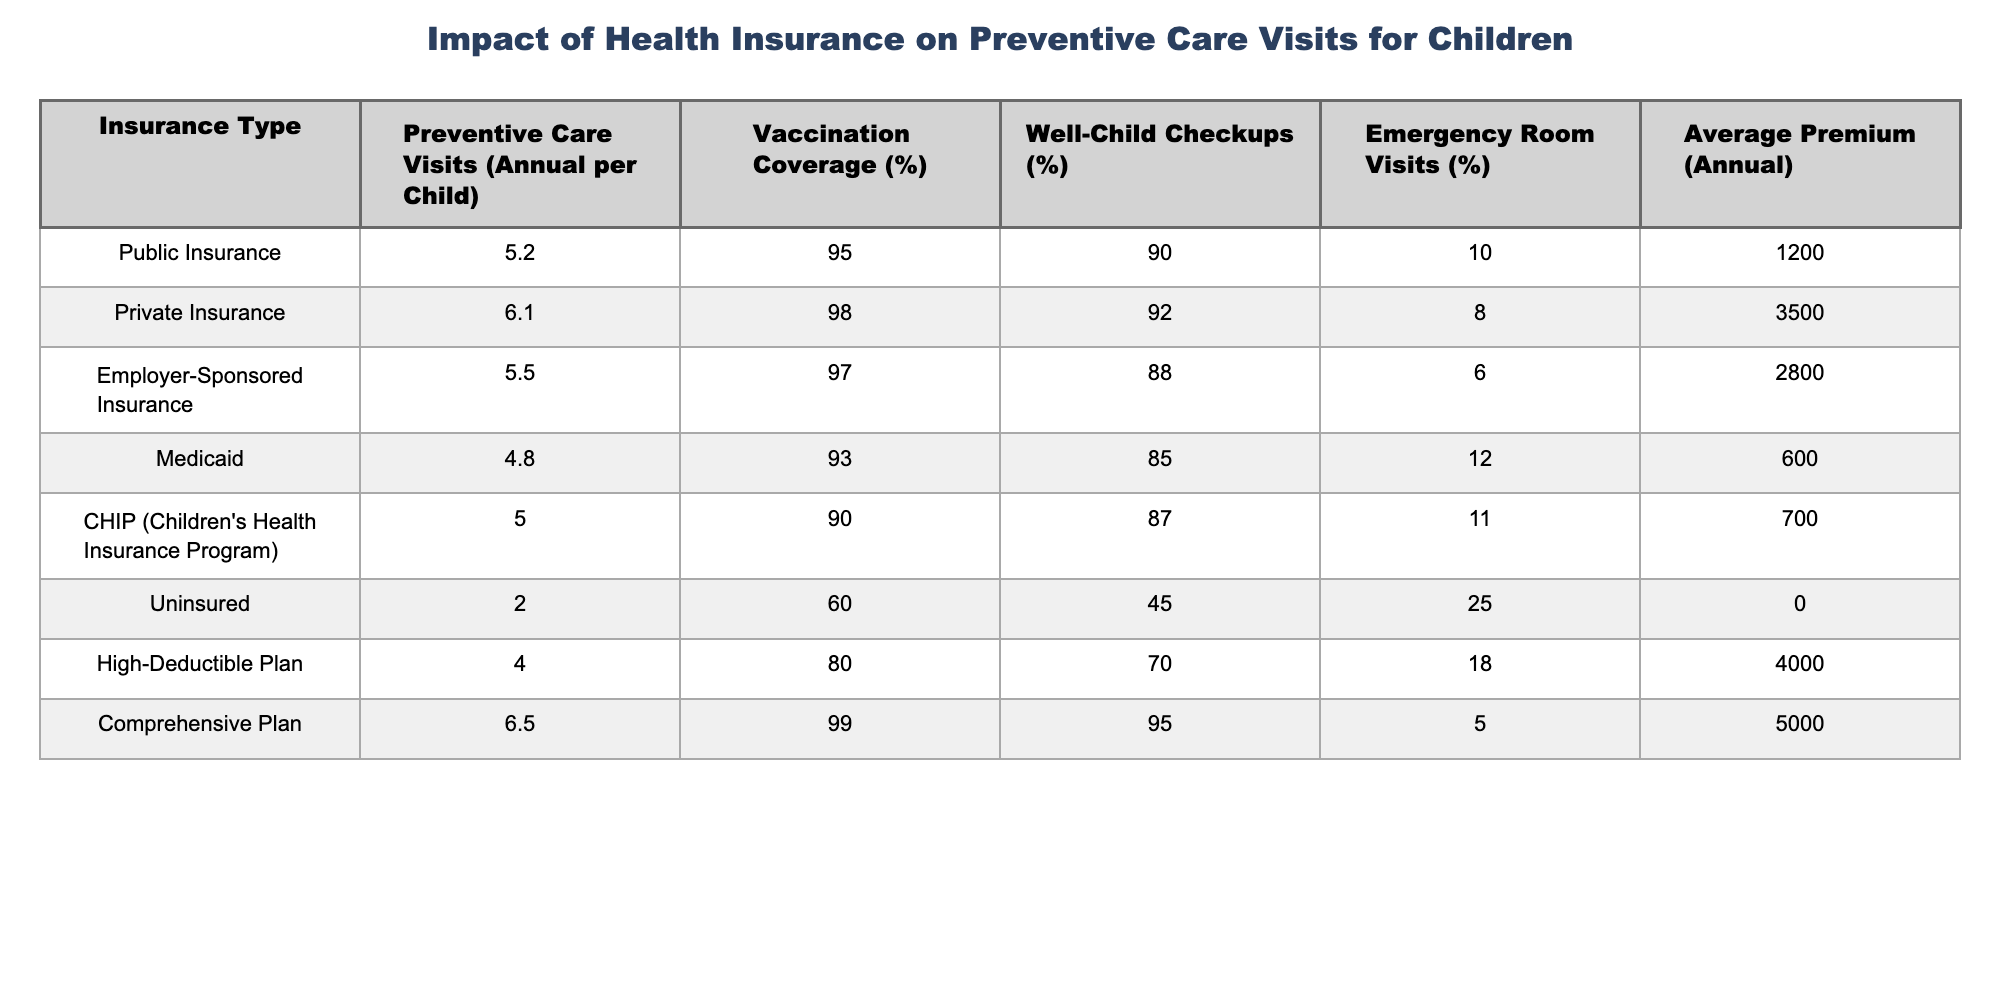What is the average number of preventive care visits for children with private insurance? The table shows that private insurance has an annual preventive care visits rate of 6.1 per child.
Answer: 6.1 Which insurance type has the highest vaccination coverage? The table indicates that the comprehensive plan has a vaccination coverage of 99%, which is the highest among all listed insurance types.
Answer: Comprehensive Plan What is the difference in preventive care visits between children with public insurance and those who are uninsured? Public insurance provides 5.2 preventive care visits, while uninsured children receive only 2.0 visits. The difference is 5.2 - 2.0 = 3.2 visits.
Answer: 3.2 visits Is the average premium for Medicaid higher than for CHIP? The average premium for Medicaid is 600, while for CHIP it is 700. Since 600 is less than 700, the statement is false.
Answer: No What is the sum of emergency room visits percentages for public insurance and employer-sponsored insurance? Public insurance has 10% emergency room visits and employer-sponsored insurance has 6%. Adding these together gives 10 + 6 = 16.
Answer: 16% What percentage of children covered by public insurance receive well-child checkups? According to the table, 90% of children with public insurance receive well-child checkups.
Answer: 90% If a family has a comprehensive plan, how much higher is the annual premium compared to having Medicaid? The comprehensive plan has an annual premium of 5000, while Medicaid has 600, leading to a difference of 5000 - 600 = 4400.
Answer: 4400 Which plan has the lowest vaccination coverage and what is that percentage? The CHIP plan has the lowest vaccination coverage at 90%.
Answer: 90% How many more well-child checkups do children with private insurance receive compared to those with high-deductible plans? Private insurance has 92% well-child checkups and high-deductible plans have 70%. The difference is 92 - 70 = 22%.
Answer: 22% If a child is uninsured, what is the likelihood (percentage) that they will have a preventive care visit? The table indicates that uninsured children have only 2.0 preventive care visits per year, which implies a low likelihood of visits. This could be interpreted relative to 6.1 visits with private insurance.
Answer: Very low likelihood 